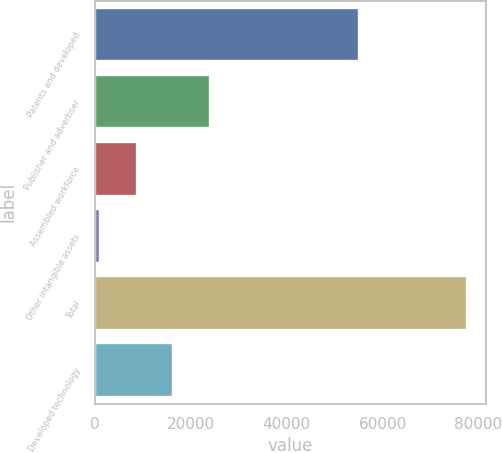Convert chart. <chart><loc_0><loc_0><loc_500><loc_500><bar_chart><fcel>Patents and developed<fcel>Publisher and advertiser<fcel>Assembled workforce<fcel>Other intangible assets<fcel>Total<fcel>Developed technology<nl><fcel>55113<fcel>23989.5<fcel>8664.5<fcel>1002<fcel>77627<fcel>16327<nl></chart> 